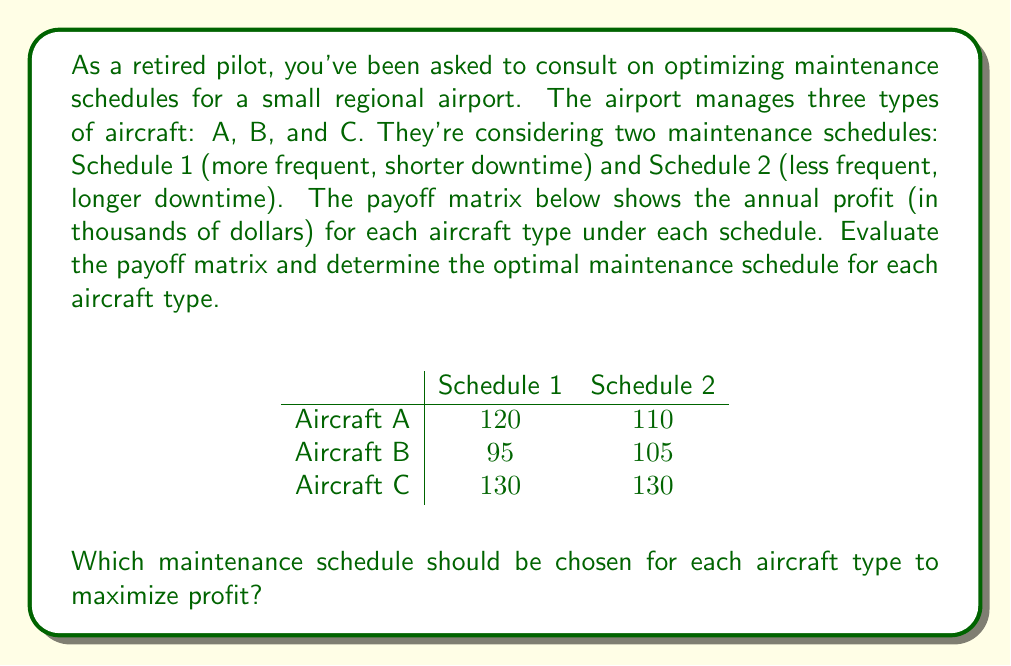Can you solve this math problem? To solve this problem, we need to evaluate the payoff matrix for each aircraft type:

1. For Aircraft A:
   - Schedule 1 yields $120,000 profit
   - Schedule 2 yields $110,000 profit
   $120,000 > 110,000$, so Schedule 1 is optimal for Aircraft A.

2. For Aircraft B:
   - Schedule 1 yields $95,000 profit
   - Schedule 2 yields $105,000 profit
   $105,000 > 95,000$, so Schedule 2 is optimal for Aircraft B.

3. For Aircraft C:
   - Both Schedule 1 and Schedule 2 yield $130,000 profit
   Since the payoffs are equal, either schedule can be chosen for Aircraft C.

The optimal strategy is to choose the schedule that maximizes profit for each aircraft type. In game theory, this is known as a dominant strategy, where one option yields a higher payoff regardless of what other players (in this case, other aircraft types) choose.
Answer: The optimal maintenance schedules are:
- Aircraft A: Schedule 1
- Aircraft B: Schedule 2
- Aircraft C: Either Schedule 1 or Schedule 2 (indifferent) 